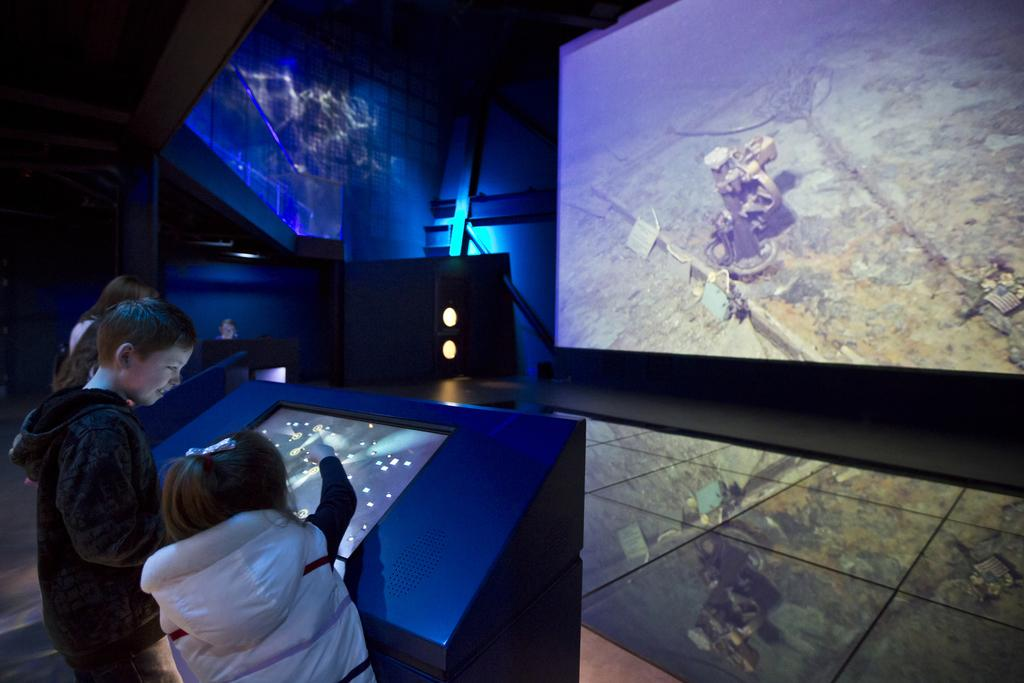How many people are in the image? There are persons standing in the image. What is the surface on which the persons are standing? The persons are standing on the floor. What is in front of the persons? There are screens and lights in front of the persons. What can be seen in the background of the image? There is a wall visible in the background of the image. What type of cub can be seen playing with a knife in the image? There is no cub or knife present in the image. 